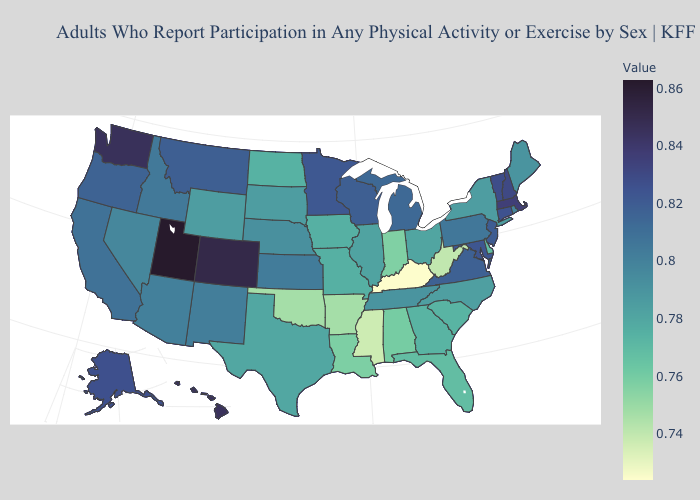Which states hav the highest value in the West?
Give a very brief answer. Utah. Which states have the highest value in the USA?
Keep it brief. Utah. Does Oklahoma have a lower value than Kentucky?
Keep it brief. No. Among the states that border Arkansas , which have the highest value?
Short answer required. Tennessee. Among the states that border North Dakota , does Minnesota have the highest value?
Answer briefly. Yes. 